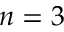<formula> <loc_0><loc_0><loc_500><loc_500>n = 3</formula> 